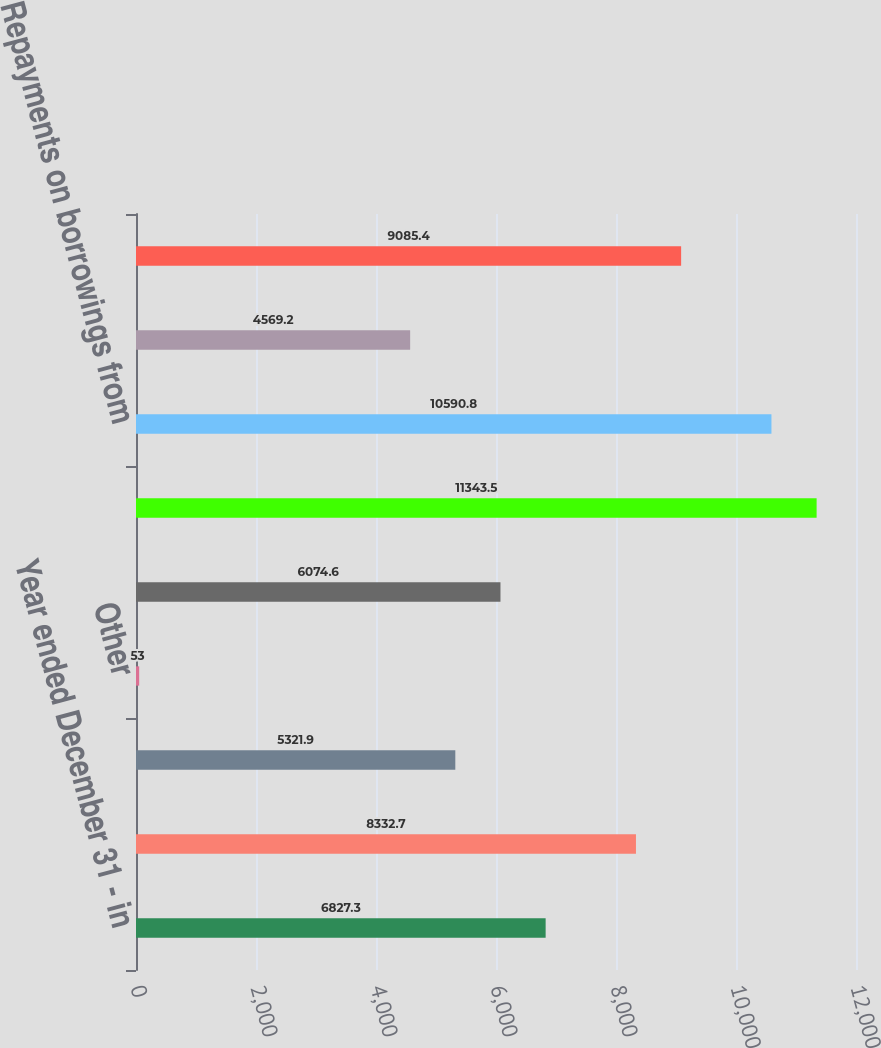Convert chart. <chart><loc_0><loc_0><loc_500><loc_500><bar_chart><fcel>Year ended December 31 - in<fcel>Net income<fcel>Equity in undistributed net<fcel>Other<fcel>Net cash provided (used) by<fcel>Borrowings from subsidiaries<fcel>Repayments on borrowings from<fcel>Other borrowed funds<fcel>Common and treasury stock<nl><fcel>6827.3<fcel>8332.7<fcel>5321.9<fcel>53<fcel>6074.6<fcel>11343.5<fcel>10590.8<fcel>4569.2<fcel>9085.4<nl></chart> 